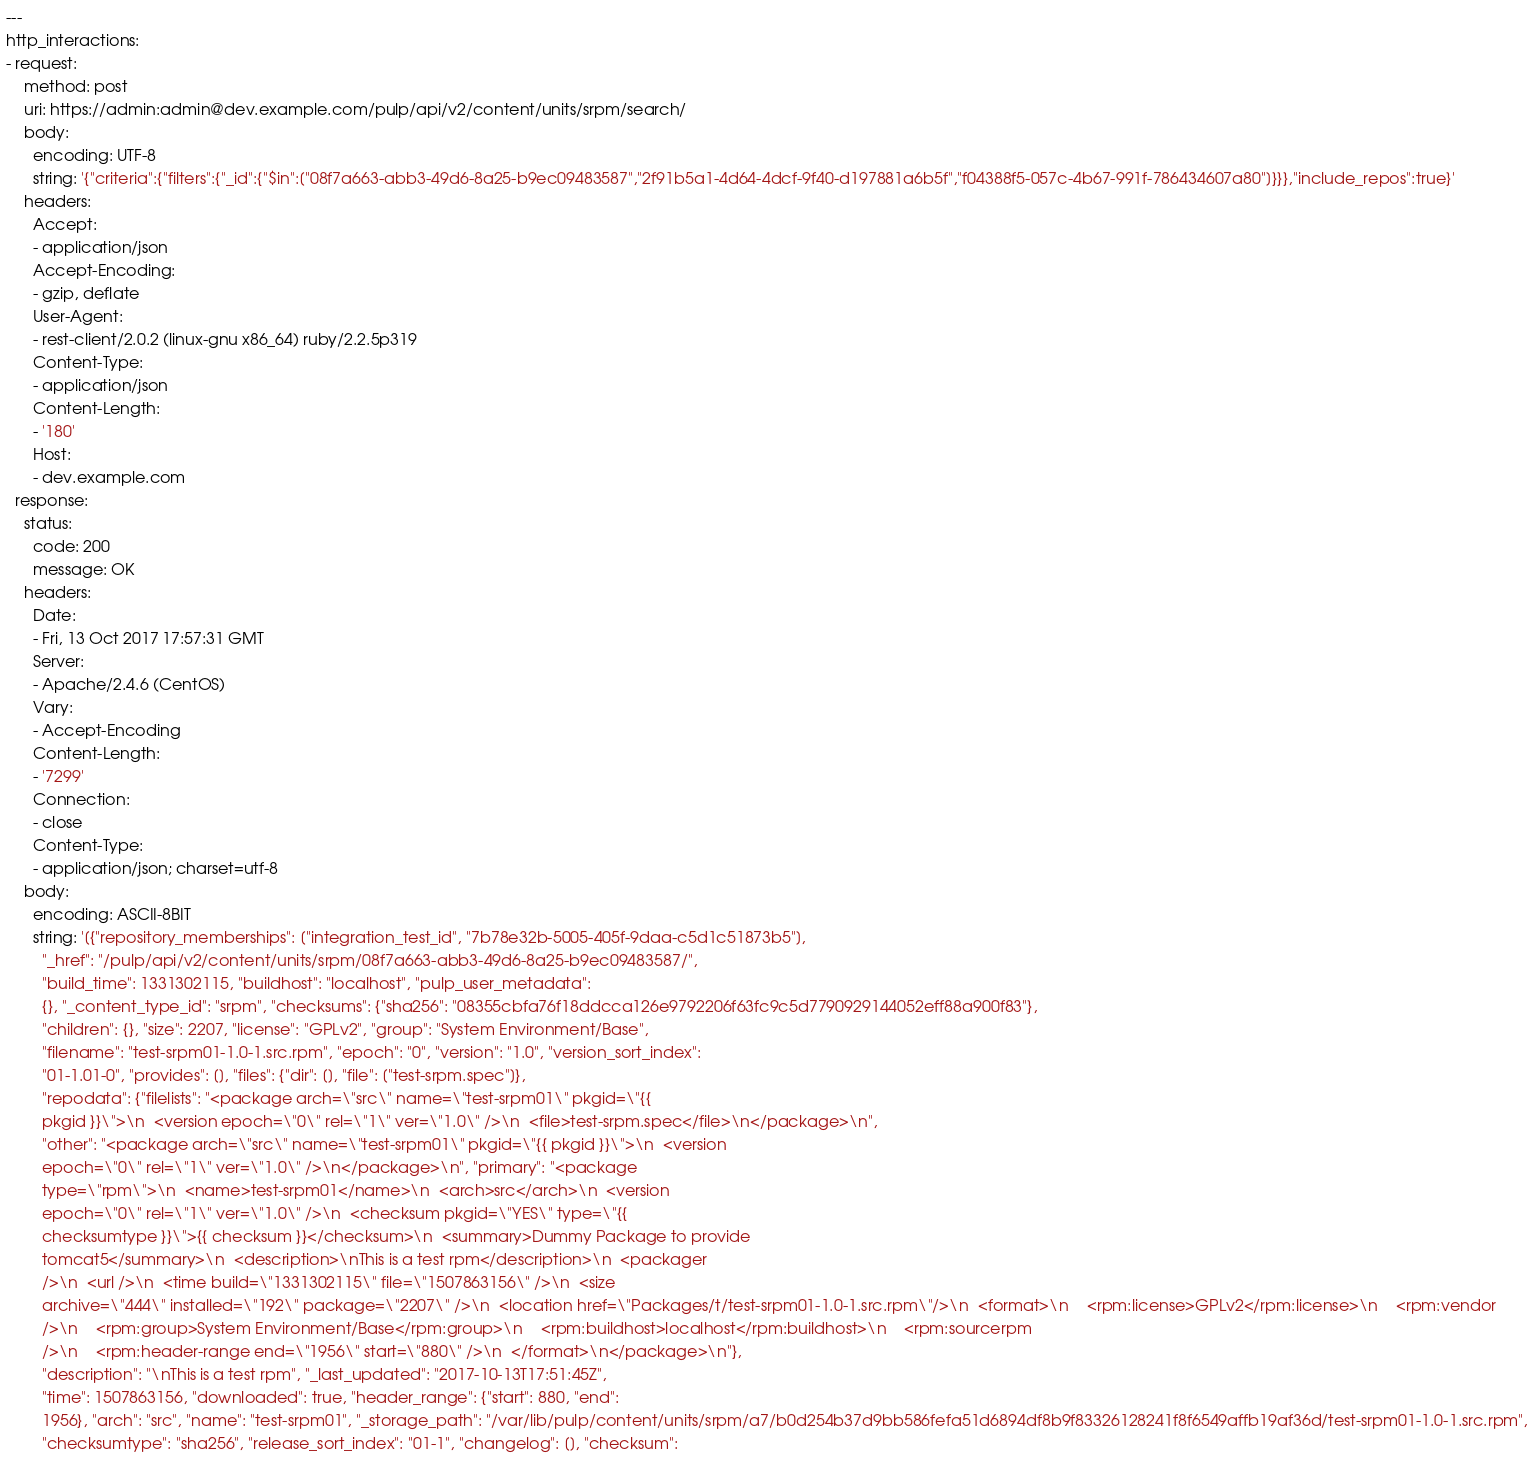<code> <loc_0><loc_0><loc_500><loc_500><_YAML_>---
http_interactions:
- request:
    method: post
    uri: https://admin:admin@dev.example.com/pulp/api/v2/content/units/srpm/search/
    body:
      encoding: UTF-8
      string: '{"criteria":{"filters":{"_id":{"$in":["08f7a663-abb3-49d6-8a25-b9ec09483587","2f91b5a1-4d64-4dcf-9f40-d197881a6b5f","f04388f5-057c-4b67-991f-786434607a80"]}}},"include_repos":true}'
    headers:
      Accept:
      - application/json
      Accept-Encoding:
      - gzip, deflate
      User-Agent:
      - rest-client/2.0.2 (linux-gnu x86_64) ruby/2.2.5p319
      Content-Type:
      - application/json
      Content-Length:
      - '180'
      Host:
      - dev.example.com
  response:
    status:
      code: 200
      message: OK
    headers:
      Date:
      - Fri, 13 Oct 2017 17:57:31 GMT
      Server:
      - Apache/2.4.6 (CentOS)
      Vary:
      - Accept-Encoding
      Content-Length:
      - '7299'
      Connection:
      - close
      Content-Type:
      - application/json; charset=utf-8
    body:
      encoding: ASCII-8BIT
      string: '[{"repository_memberships": ["integration_test_id", "7b78e32b-5005-405f-9daa-c5d1c51873b5"],
        "_href": "/pulp/api/v2/content/units/srpm/08f7a663-abb3-49d6-8a25-b9ec09483587/",
        "build_time": 1331302115, "buildhost": "localhost", "pulp_user_metadata":
        {}, "_content_type_id": "srpm", "checksums": {"sha256": "08355cbfa76f18ddcca126e9792206f63fc9c5d7790929144052eff88a900f83"},
        "children": {}, "size": 2207, "license": "GPLv2", "group": "System Environment/Base",
        "filename": "test-srpm01-1.0-1.src.rpm", "epoch": "0", "version": "1.0", "version_sort_index":
        "01-1.01-0", "provides": [], "files": {"dir": [], "file": ["test-srpm.spec"]},
        "repodata": {"filelists": "<package arch=\"src\" name=\"test-srpm01\" pkgid=\"{{
        pkgid }}\">\n  <version epoch=\"0\" rel=\"1\" ver=\"1.0\" />\n  <file>test-srpm.spec</file>\n</package>\n",
        "other": "<package arch=\"src\" name=\"test-srpm01\" pkgid=\"{{ pkgid }}\">\n  <version
        epoch=\"0\" rel=\"1\" ver=\"1.0\" />\n</package>\n", "primary": "<package
        type=\"rpm\">\n  <name>test-srpm01</name>\n  <arch>src</arch>\n  <version
        epoch=\"0\" rel=\"1\" ver=\"1.0\" />\n  <checksum pkgid=\"YES\" type=\"{{
        checksumtype }}\">{{ checksum }}</checksum>\n  <summary>Dummy Package to provide
        tomcat5</summary>\n  <description>\nThis is a test rpm</description>\n  <packager
        />\n  <url />\n  <time build=\"1331302115\" file=\"1507863156\" />\n  <size
        archive=\"444\" installed=\"192\" package=\"2207\" />\n  <location href=\"Packages/t/test-srpm01-1.0-1.src.rpm\"/>\n  <format>\n    <rpm:license>GPLv2</rpm:license>\n    <rpm:vendor
        />\n    <rpm:group>System Environment/Base</rpm:group>\n    <rpm:buildhost>localhost</rpm:buildhost>\n    <rpm:sourcerpm
        />\n    <rpm:header-range end=\"1956\" start=\"880\" />\n  </format>\n</package>\n"},
        "description": "\nThis is a test rpm", "_last_updated": "2017-10-13T17:51:45Z",
        "time": 1507863156, "downloaded": true, "header_range": {"start": 880, "end":
        1956}, "arch": "src", "name": "test-srpm01", "_storage_path": "/var/lib/pulp/content/units/srpm/a7/b0d254b37d9bb586fefa51d6894df8b9f83326128241f8f6549affb19af36d/test-srpm01-1.0-1.src.rpm",
        "checksumtype": "sha256", "release_sort_index": "01-1", "changelog": [], "checksum":</code> 